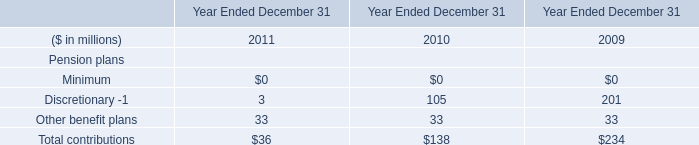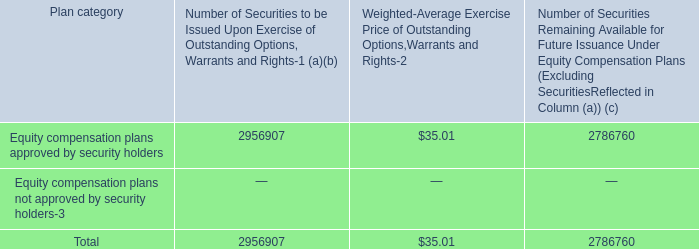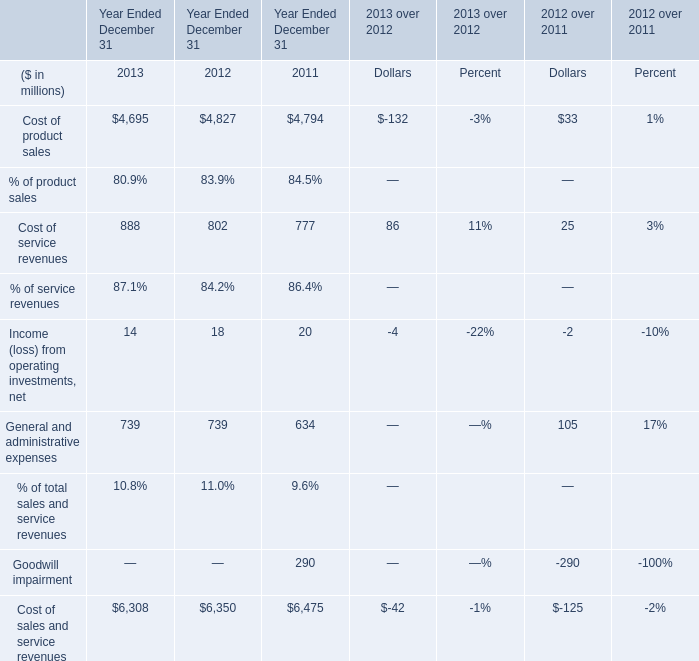In the year with lowest amount of Cost of sales and service revenues, what's the increasing rate of Cost of product sales? 
Computations: ((4695 - 4827) / 4827)
Answer: -0.02735. 